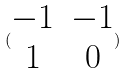Convert formula to latex. <formula><loc_0><loc_0><loc_500><loc_500>( \begin{matrix} - 1 & - 1 \\ 1 & 0 \end{matrix} )</formula> 